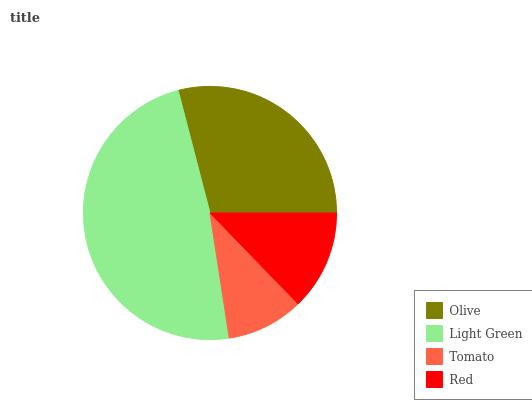Is Tomato the minimum?
Answer yes or no. Yes. Is Light Green the maximum?
Answer yes or no. Yes. Is Light Green the minimum?
Answer yes or no. No. Is Tomato the maximum?
Answer yes or no. No. Is Light Green greater than Tomato?
Answer yes or no. Yes. Is Tomato less than Light Green?
Answer yes or no. Yes. Is Tomato greater than Light Green?
Answer yes or no. No. Is Light Green less than Tomato?
Answer yes or no. No. Is Olive the high median?
Answer yes or no. Yes. Is Red the low median?
Answer yes or no. Yes. Is Red the high median?
Answer yes or no. No. Is Tomato the low median?
Answer yes or no. No. 